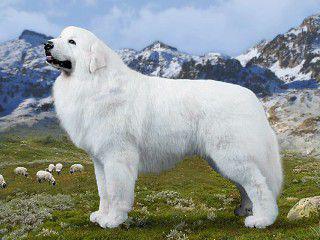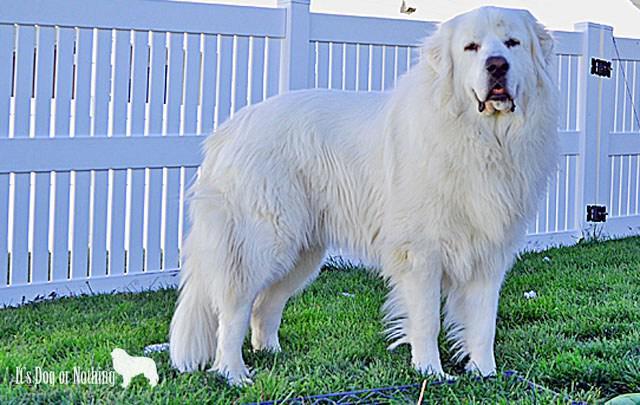The first image is the image on the left, the second image is the image on the right. Examine the images to the left and right. Is the description "There are two dogs in the image pair, both facing the same direction as the other." accurate? Answer yes or no. No. The first image is the image on the left, the second image is the image on the right. Evaluate the accuracy of this statement regarding the images: "An image contains one white dog standing in profile and turned leftward.". Is it true? Answer yes or no. Yes. 